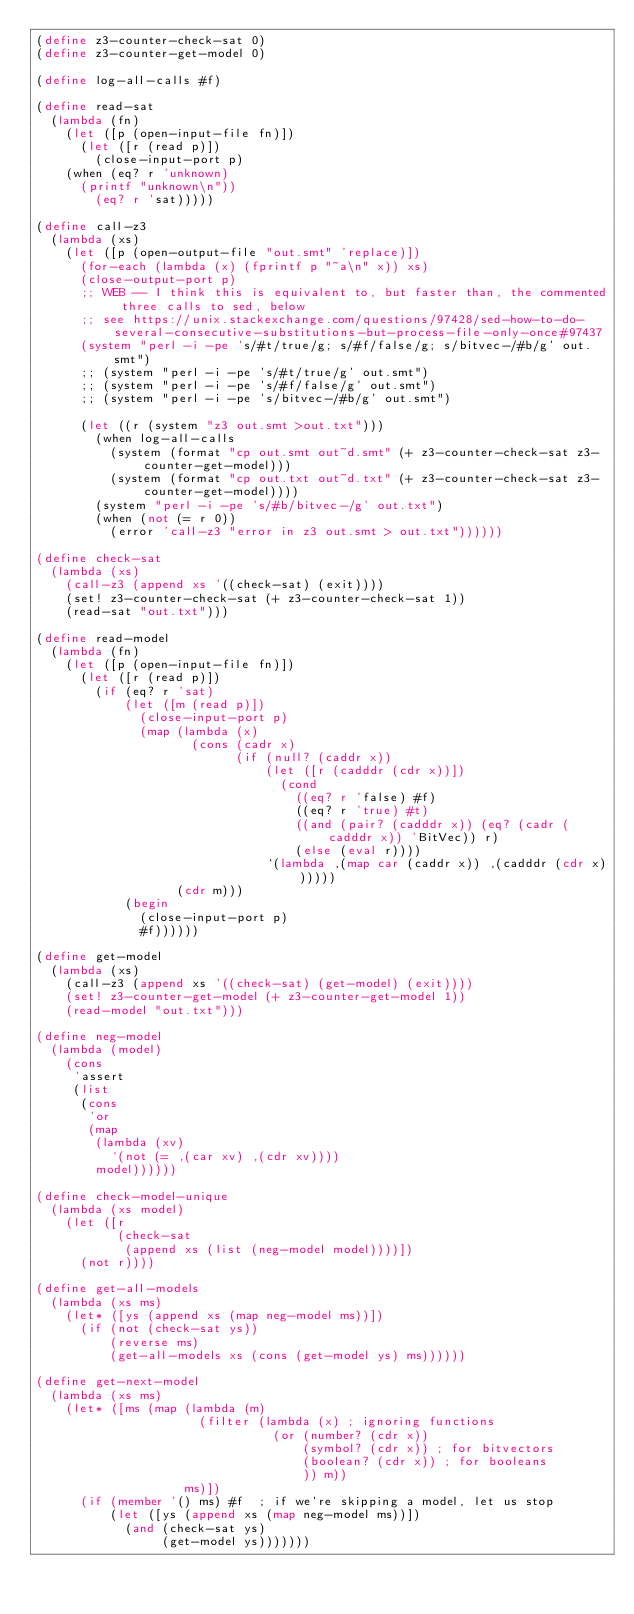<code> <loc_0><loc_0><loc_500><loc_500><_Scheme_>(define z3-counter-check-sat 0)
(define z3-counter-get-model 0)

(define log-all-calls #f)

(define read-sat
  (lambda (fn)
    (let ([p (open-input-file fn)])
      (let ([r (read p)])
        (close-input-port p)
	(when (eq? r 'unknown)
	  (printf "unknown\n"))
        (eq? r 'sat)))))

(define call-z3
  (lambda (xs)
    (let ([p (open-output-file "out.smt" 'replace)])
      (for-each (lambda (x) (fprintf p "~a\n" x)) xs)
      (close-output-port p)
      ;; WEB -- I think this is equivalent to, but faster than, the commented three calls to sed, below
      ;; see https://unix.stackexchange.com/questions/97428/sed-how-to-do-several-consecutive-substitutions-but-process-file-only-once#97437
      (system "perl -i -pe 's/#t/true/g; s/#f/false/g; s/bitvec-/#b/g' out.smt")
      ;; (system "perl -i -pe 's/#t/true/g' out.smt")
      ;; (system "perl -i -pe 's/#f/false/g' out.smt")
      ;; (system "perl -i -pe 's/bitvec-/#b/g' out.smt")
      
      (let ((r (system "z3 out.smt >out.txt")))
        (when log-all-calls
          (system (format "cp out.smt out~d.smt" (+ z3-counter-check-sat z3-counter-get-model)))
          (system (format "cp out.txt out~d.txt" (+ z3-counter-check-sat z3-counter-get-model))))
        (system "perl -i -pe 's/#b/bitvec-/g' out.txt")
        (when (not (= r 0))
          (error 'call-z3 "error in z3 out.smt > out.txt"))))))

(define check-sat
  (lambda (xs)
    (call-z3 (append xs '((check-sat) (exit))))
    (set! z3-counter-check-sat (+ z3-counter-check-sat 1))
    (read-sat "out.txt")))

(define read-model
  (lambda (fn)
    (let ([p (open-input-file fn)])
      (let ([r (read p)])
        (if (eq? r 'sat)
            (let ([m (read p)])
              (close-input-port p)
              (map (lambda (x)
                     (cons (cadr x)
                           (if (null? (caddr x))
                               (let ([r (cadddr (cdr x))])
                                 (cond
                                   ((eq? r 'false) #f)
                                   ((eq? r 'true) #t)
                                   ((and (pair? (cadddr x)) (eq? (cadr (cadddr x)) 'BitVec)) r)
                                   (else (eval r))))
                               `(lambda ,(map car (caddr x)) ,(cadddr (cdr x))))))
                   (cdr m)))
            (begin
              (close-input-port p)
              #f))))))

(define get-model
  (lambda (xs)
    (call-z3 (append xs '((check-sat) (get-model) (exit))))
    (set! z3-counter-get-model (+ z3-counter-get-model 1))
    (read-model "out.txt")))

(define neg-model
  (lambda (model)
    (cons
     'assert
     (list
      (cons
       'or
       (map
        (lambda (xv)
          `(not (= ,(car xv) ,(cdr xv))))
        model))))))

(define check-model-unique
  (lambda (xs model)
    (let ([r
           (check-sat
            (append xs (list (neg-model model))))])
      (not r))))

(define get-all-models
  (lambda (xs ms)
    (let* ([ys (append xs (map neg-model ms))])
      (if (not (check-sat ys))
          (reverse ms)
          (get-all-models xs (cons (get-model ys) ms))))))

(define get-next-model
  (lambda (xs ms)
    (let* ([ms (map (lambda (m)
                      (filter (lambda (x) ; ignoring functions
                                (or (number? (cdr x))
                                    (symbol? (cdr x)) ; for bitvectors
                                    (boolean? (cdr x)) ; for booleans
                                    )) m))
                    ms)])
      (if (member '() ms) #f  ; if we're skipping a model, let us stop
          (let ([ys (append xs (map neg-model ms))])
            (and (check-sat ys)
                 (get-model ys)))))))
</code> 